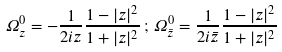Convert formula to latex. <formula><loc_0><loc_0><loc_500><loc_500>\Omega _ { z } ^ { 0 } = - \frac { 1 } { 2 i z } \frac { 1 - | z | ^ { 2 } } { 1 + | z | ^ { 2 } } \, ; \, \Omega _ { \bar { z } } ^ { 0 } = \frac { 1 } { 2 i \bar { z } } \frac { 1 - | z | ^ { 2 } } { 1 + | z | ^ { 2 } }</formula> 